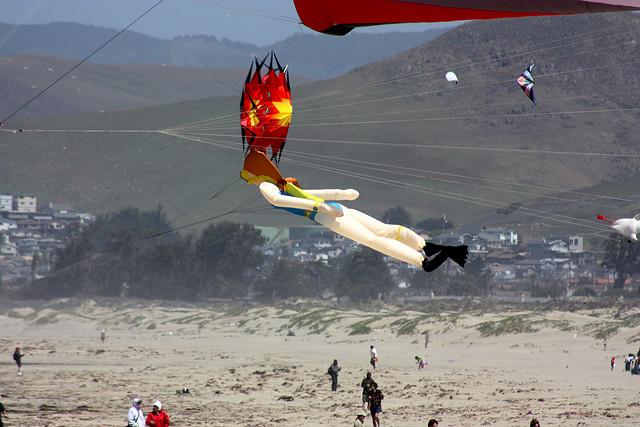Write a detailed description of the given image. The image depicts a beach scene with multiple kites in the sky. In the upper right, a diamond-shaped kite is soaring. At the far right edge, another kite is almost touching the boundary. The most prominent kite, positioned centrally, resembles a humanoid figure with vivid colors of red, yellow, and black, appearing fiery. Amidst the sandy area below, several individuals are visible, many of whom are wearing jackets. Specifically, one person clad in a jacket is located to the far left, while others are gathered more towards the center and right of the image. In the background, there are rolling hills and a cluster of buildings, suggesting the presence of a coastal town. 